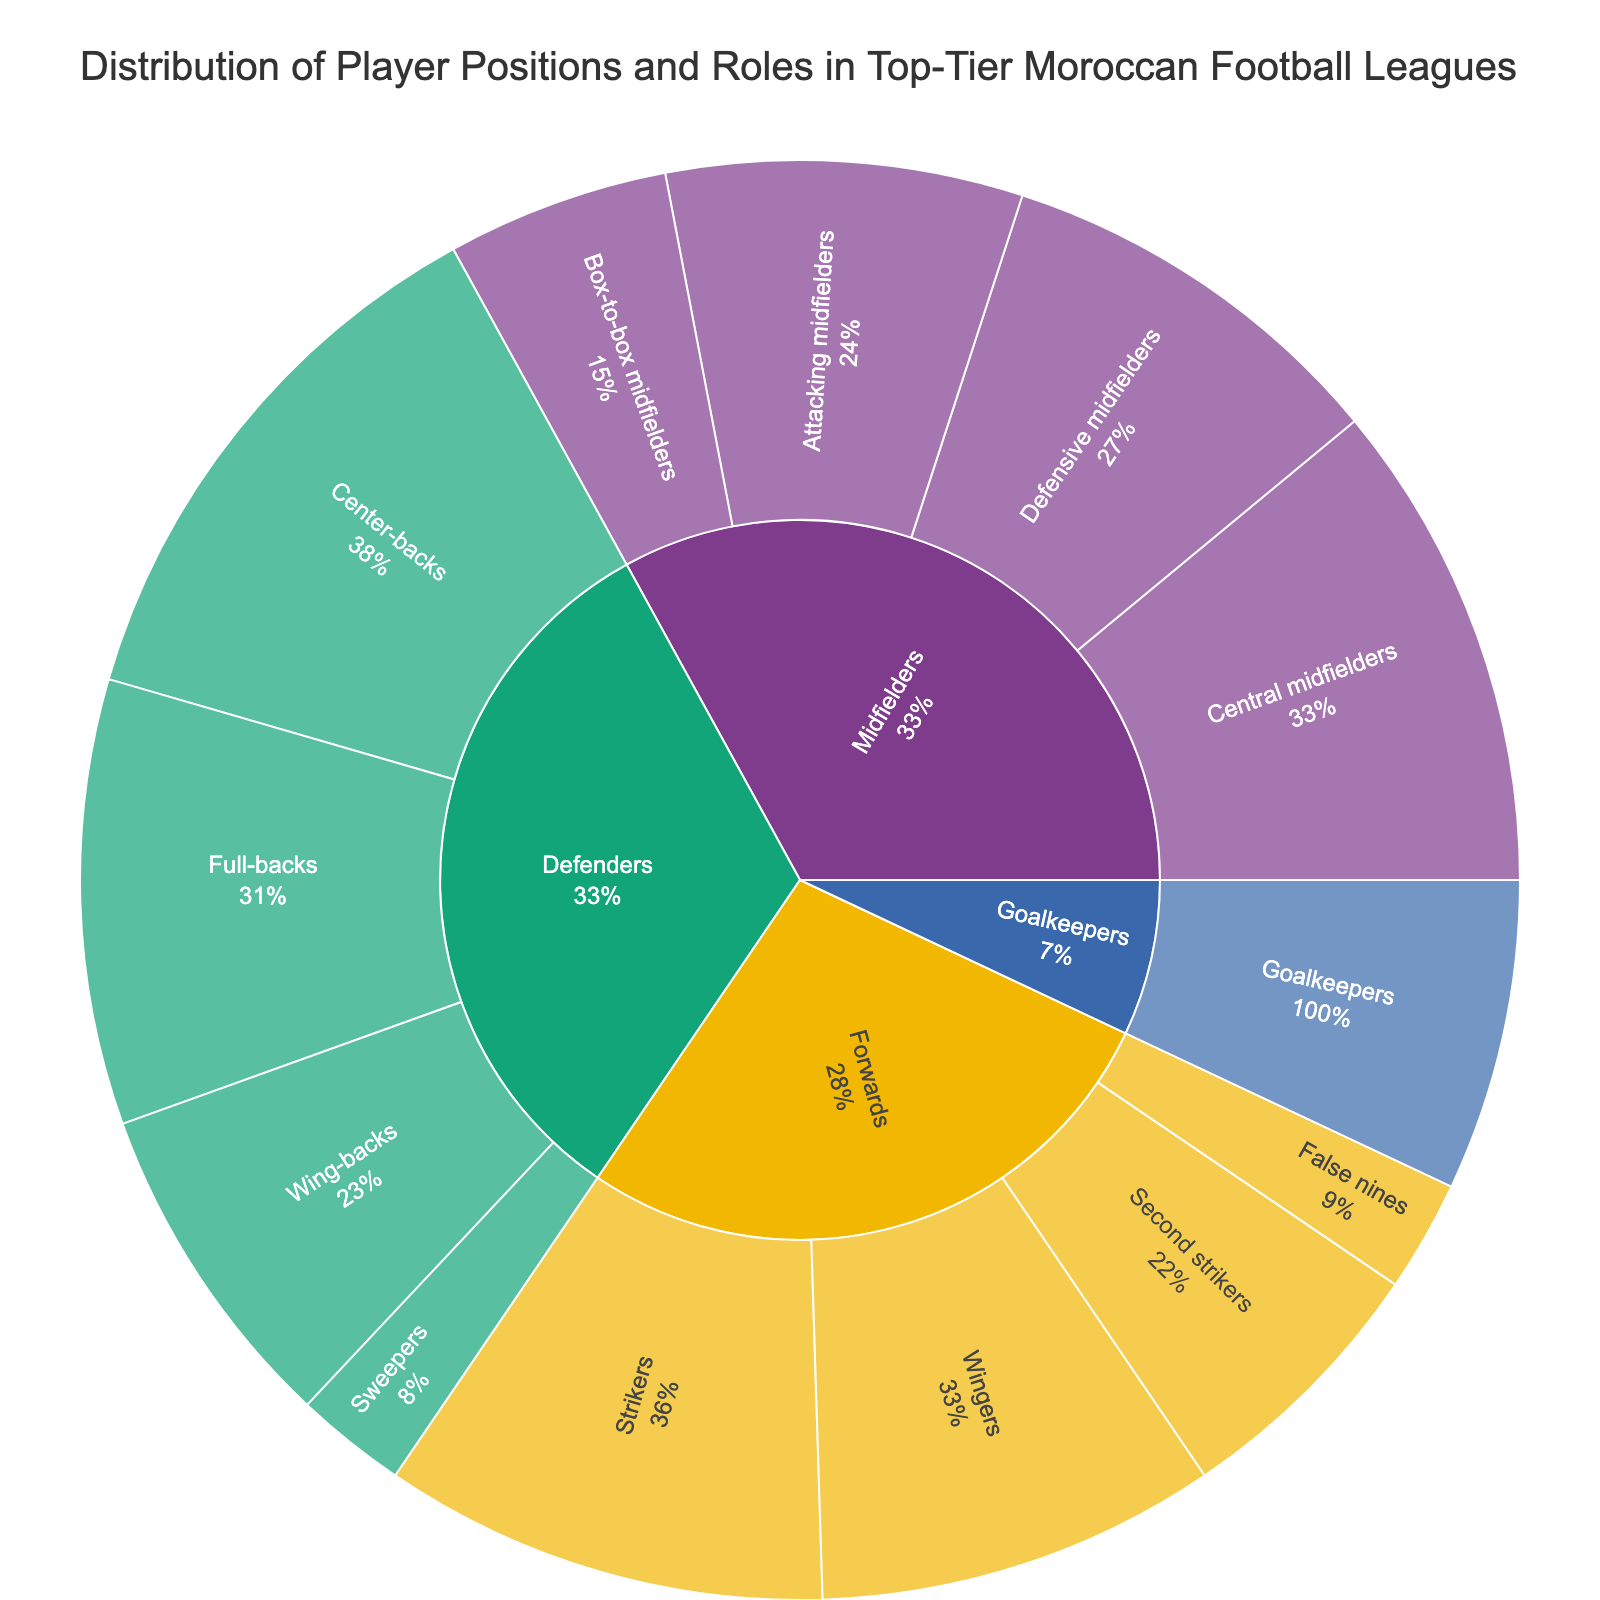What's the title of the figure? The title is often at the top or in a prominent location and usually provides information about what the figure represents. Here, it reads: "Distribution of Player Positions and Roles in Top-Tier Moroccan Football Leagues".
Answer: Distribution of Player Positions and Roles in Top-Tier Moroccan Football Leagues How many positions are listed under the ‘Defenders’ category? The figure seems to categorize player roles under broader categories. For 'Defenders', count each subcategory listed within the 'Defenders' segment. The subcategories are Center-backs, Full-backs, Wing-backs, and Sweepers.
Answer: 4 Which position has the most players in the 'Defenders' category? Look at the size of each block within the 'Defenders' section. The largest block represents Center-backs with a value of 25 players.
Answer: Center-backs What is the total number of players in the 'Forwards' category? Sum up the values of all subcategories within 'Forwards'. The values are Strikers (20), Wingers (18), Second strikers (12), and False nines (5). So, 20 + 18 + 12 + 5 = 55.
Answer: 55 Which category, 'Midfielders' or 'Forwards', has more players? Add the total number of players in each category. For 'Midfielders': Central midfielders (22), Defensive midfielders (18), Attacking midfielders (16), and Box-to-box midfielders (10) sum to 66. For 'Forwards': the total is 55. Therefore, 'Midfielders' have more players.
Answer: Midfielders What percentage of midfielders are Defensive midfielders? To find the percentage, divide the number of Defensive midfielders by the total number of Midfielders and multiply by 100. Defensive midfielders: 18; total Midfielders: 66. (18/66) * 100 ≈ 27.27%.
Answer: 27.27% Which subcategory in the 'Midfielders' category has the fewest players? Among the subcategories under 'Midfielders', Box-to-box midfielders have the fewest players with a value of 10.
Answer: Box-to-box midfielders Compare the number of Goalkeepers to Sweeper Defenders. Which is higher? Goalkeepers have a value of 14, while Sweepers have a value of 5. Comparing the two, Goalkeepers are higher in number.
Answer: Goalkeepers What is the combined total of Central midfielders and Attacking midfielders? Add the number of players in both subcategories. Central midfielders: 22 and Attacking midfielders: 16. So, 22 + 16 = 38.
Answer: 38 What role forms a smaller percentage within their respective parent category: Second strikers or Wing-backs? Calculate the percentage for each role by dividing the role value by its parent category total. Second Strikers: 12/55 ≈ 21.82%. Wing-backs: 15/65 ≈ 23.08%. Second strikers form a smaller percentage.
Answer: Second strikers 